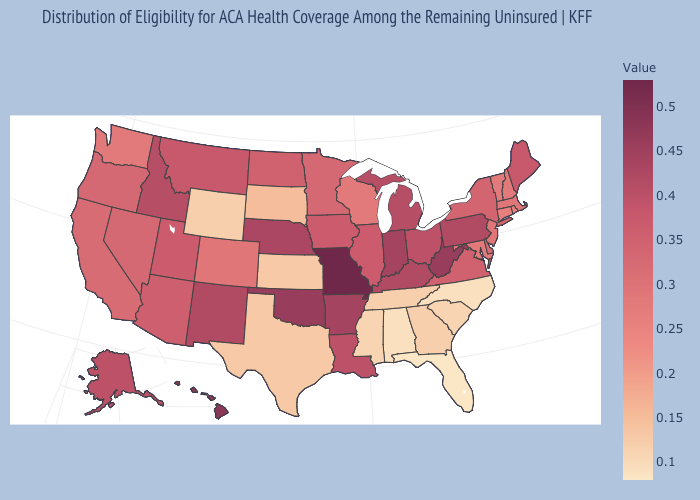Does Hawaii have the lowest value in the West?
Be succinct. No. Does Michigan have a lower value than Alabama?
Concise answer only. No. Among the states that border Missouri , does Nebraska have the highest value?
Short answer required. No. Among the states that border Wisconsin , does Iowa have the lowest value?
Quick response, please. No. Is the legend a continuous bar?
Answer briefly. Yes. 